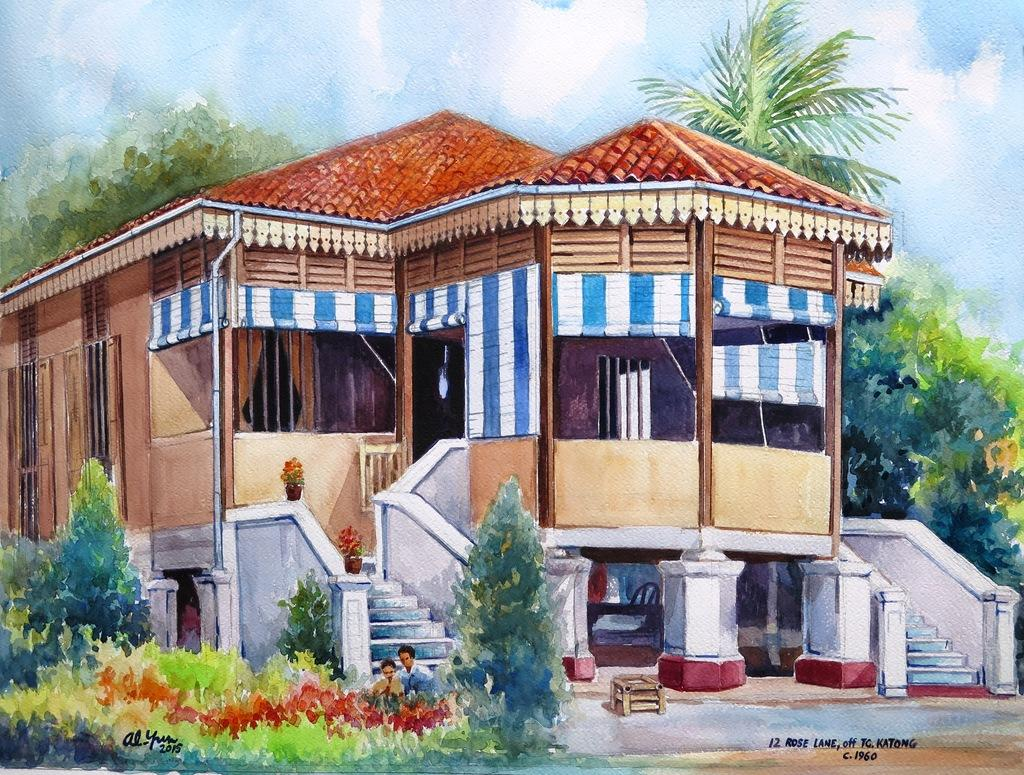What is the main subject of the painting in the image? The painting depicts a beautiful house. What can be seen around the house in the painting? There are many trees around the house in the painting. What type of driving system is used by the house in the painting? The painting does not depict any driving system, as it is a static image of a house. 